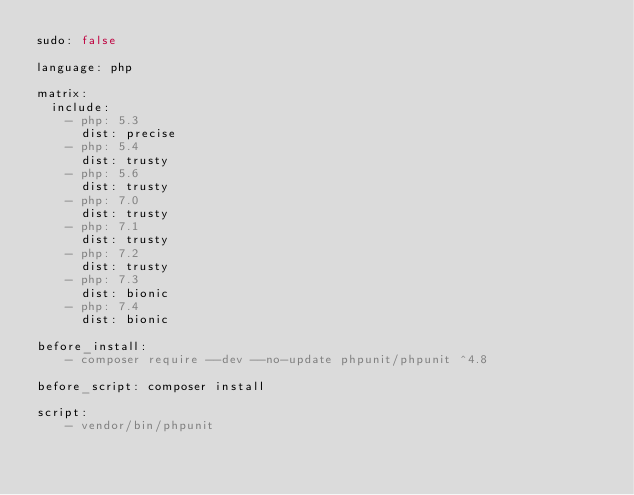Convert code to text. <code><loc_0><loc_0><loc_500><loc_500><_YAML_>sudo: false

language: php

matrix:
  include:
    - php: 5.3
      dist: precise
    - php: 5.4
      dist: trusty
    - php: 5.6
      dist: trusty
    - php: 7.0
      dist: trusty
    - php: 7.1
      dist: trusty
    - php: 7.2
      dist: trusty
    - php: 7.3
      dist: bionic
    - php: 7.4
      dist: bionic

before_install:
    - composer require --dev --no-update phpunit/phpunit ^4.8

before_script: composer install

script:
    - vendor/bin/phpunit

</code> 